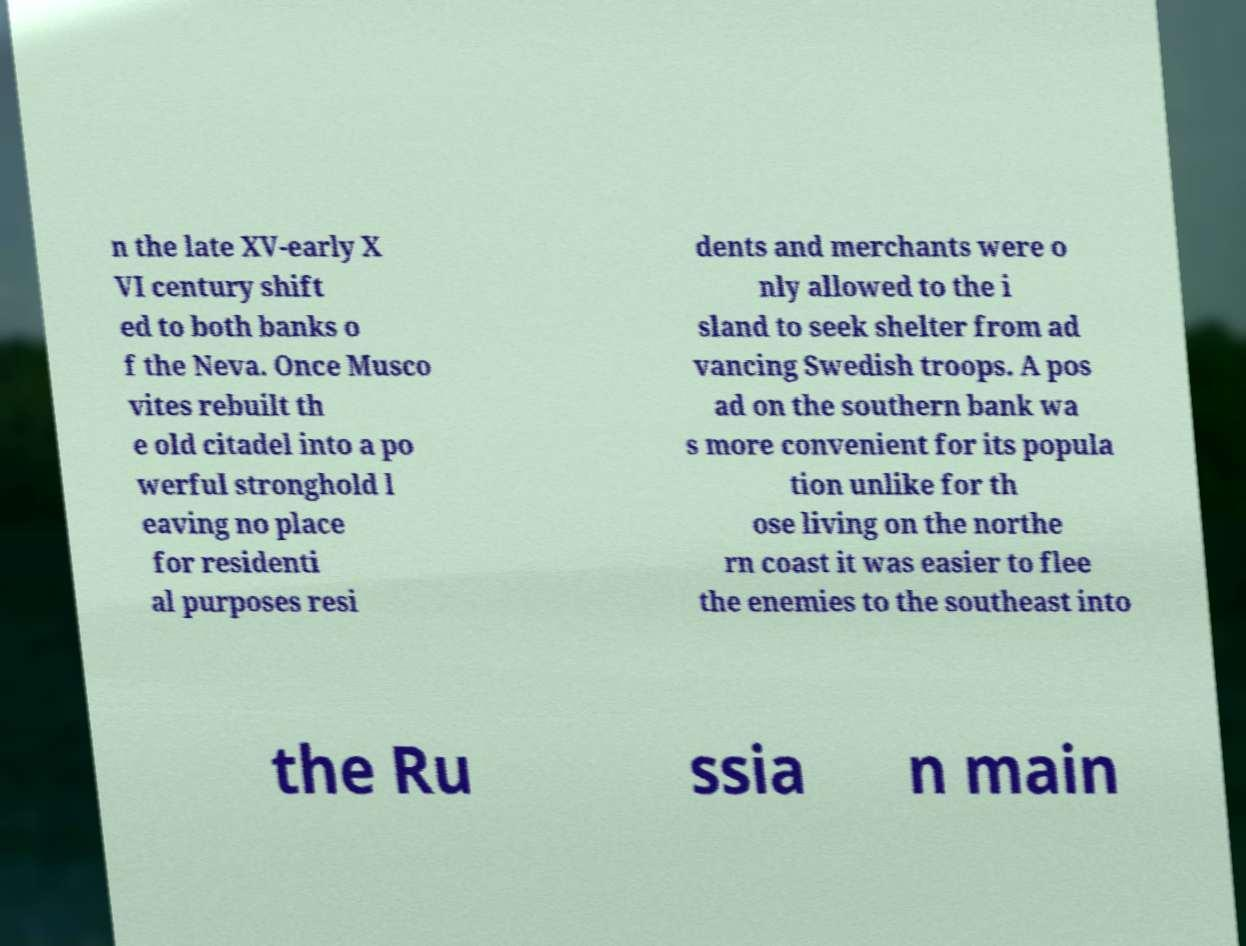I need the written content from this picture converted into text. Can you do that? n the late XV-early X VI century shift ed to both banks o f the Neva. Once Musco vites rebuilt th e old citadel into a po werful stronghold l eaving no place for residenti al purposes resi dents and merchants were o nly allowed to the i sland to seek shelter from ad vancing Swedish troops. A pos ad on the southern bank wa s more convenient for its popula tion unlike for th ose living on the northe rn coast it was easier to flee the enemies to the southeast into the Ru ssia n main 